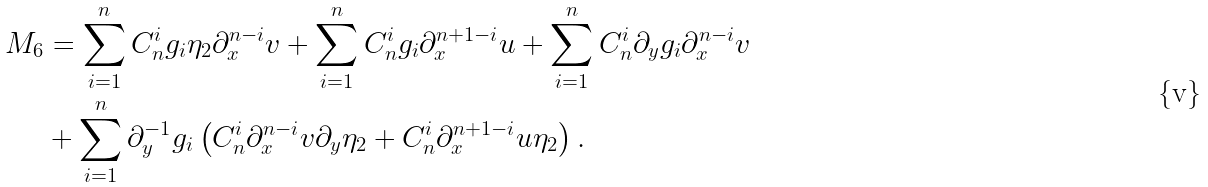<formula> <loc_0><loc_0><loc_500><loc_500>{ M } _ { 6 } & = \sum _ { i = 1 } ^ { n } C ^ { i } _ { n } g _ { i } \eta _ { 2 } \partial ^ { n - i } _ { x } { v } + \sum _ { i = 1 } ^ { n } C ^ { i } _ { n } g _ { i } \partial ^ { n + 1 - i } _ { x } { u } + \sum _ { i = 1 } ^ { n } C ^ { i } _ { n } \partial _ { y } g _ { i } \partial ^ { n - i } _ { x } { v } \\ & + \sum _ { i = 1 } ^ { n } \partial _ { y } ^ { - 1 } g _ { i } \left ( C _ { n } ^ { i } \partial ^ { n - i } _ { x } { v } \partial _ { y } \eta _ { 2 } + C _ { n } ^ { i } \partial ^ { n + 1 - i } _ { x } { u } \eta _ { 2 } \right ) .</formula> 